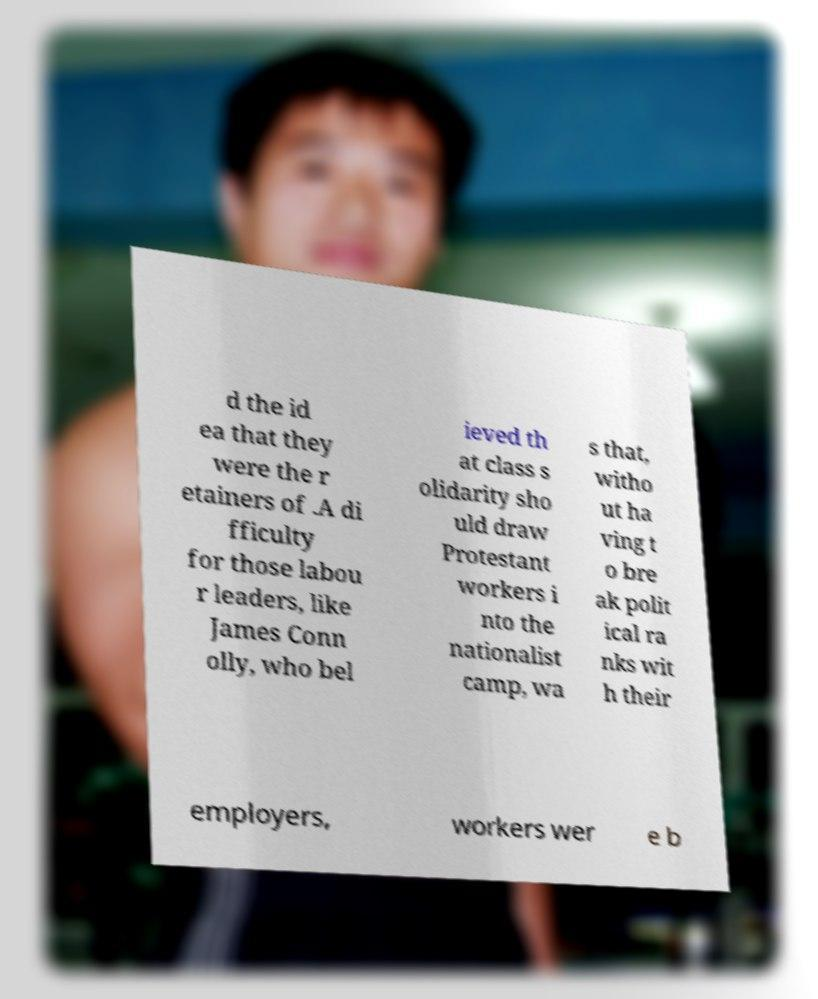Please read and relay the text visible in this image. What does it say? d the id ea that they were the r etainers of .A di fficulty for those labou r leaders, like James Conn olly, who bel ieved th at class s olidarity sho uld draw Protestant workers i nto the nationalist camp, wa s that, witho ut ha ving t o bre ak polit ical ra nks wit h their employers, workers wer e b 